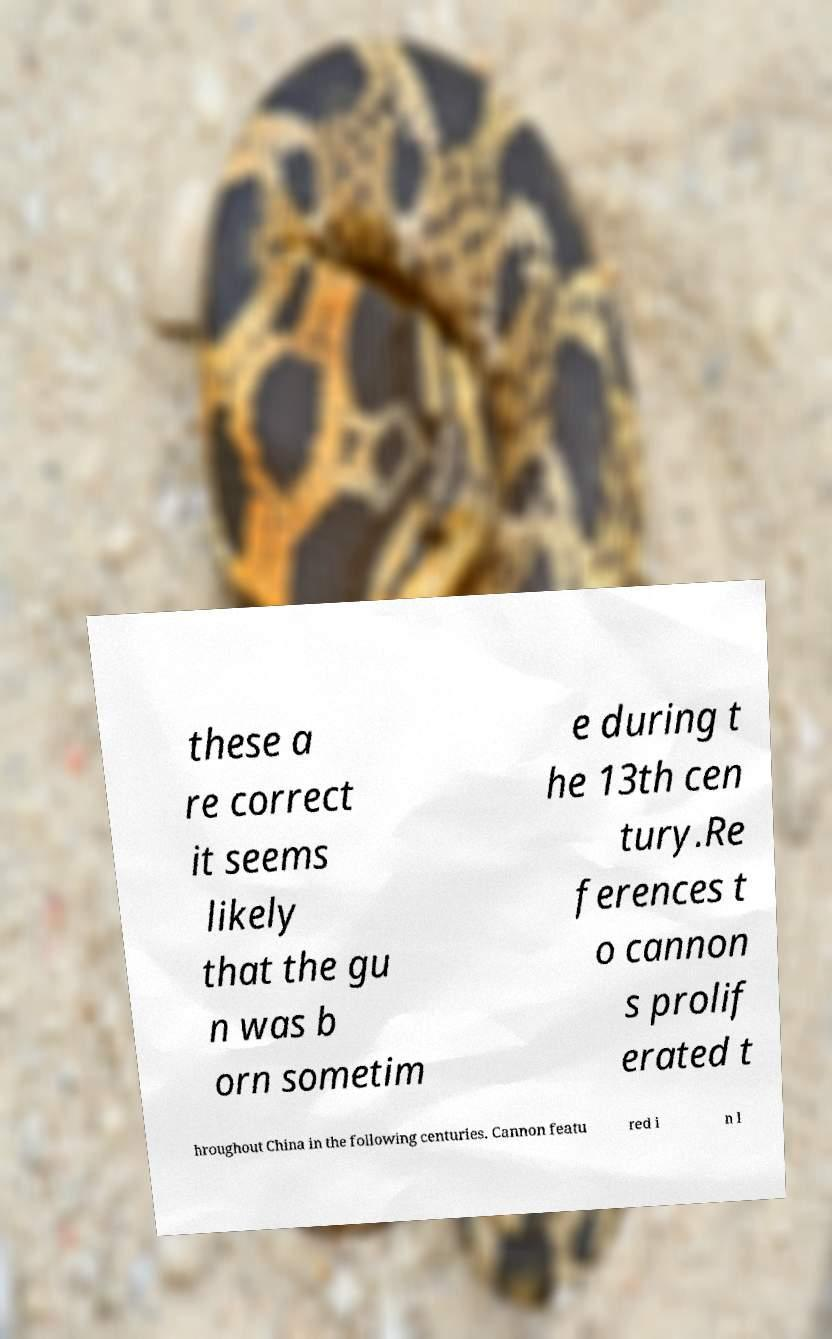Can you accurately transcribe the text from the provided image for me? these a re correct it seems likely that the gu n was b orn sometim e during t he 13th cen tury.Re ferences t o cannon s prolif erated t hroughout China in the following centuries. Cannon featu red i n l 